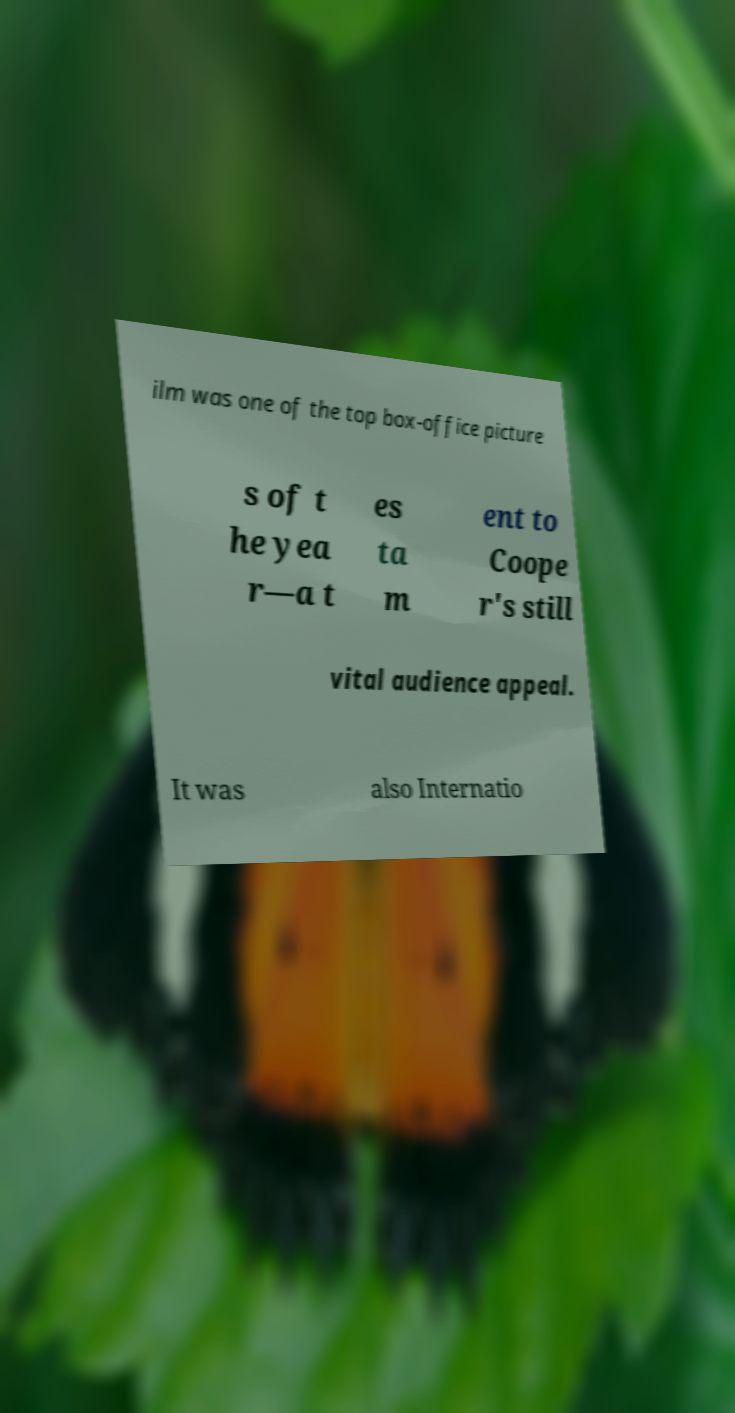Please identify and transcribe the text found in this image. ilm was one of the top box-office picture s of t he yea r—a t es ta m ent to Coope r's still vital audience appeal. It was also Internatio 